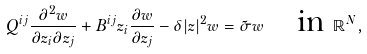Convert formula to latex. <formula><loc_0><loc_0><loc_500><loc_500>Q ^ { i j } \frac { \partial ^ { 2 } w } { \partial z _ { i } \partial z _ { j } } + B ^ { i j } z _ { i } \frac { \partial w } { \partial z _ { j } } - \delta | z | ^ { 2 } w = \tilde { \sigma } w \quad \text {in} \ \mathbb { R } ^ { N } ,</formula> 